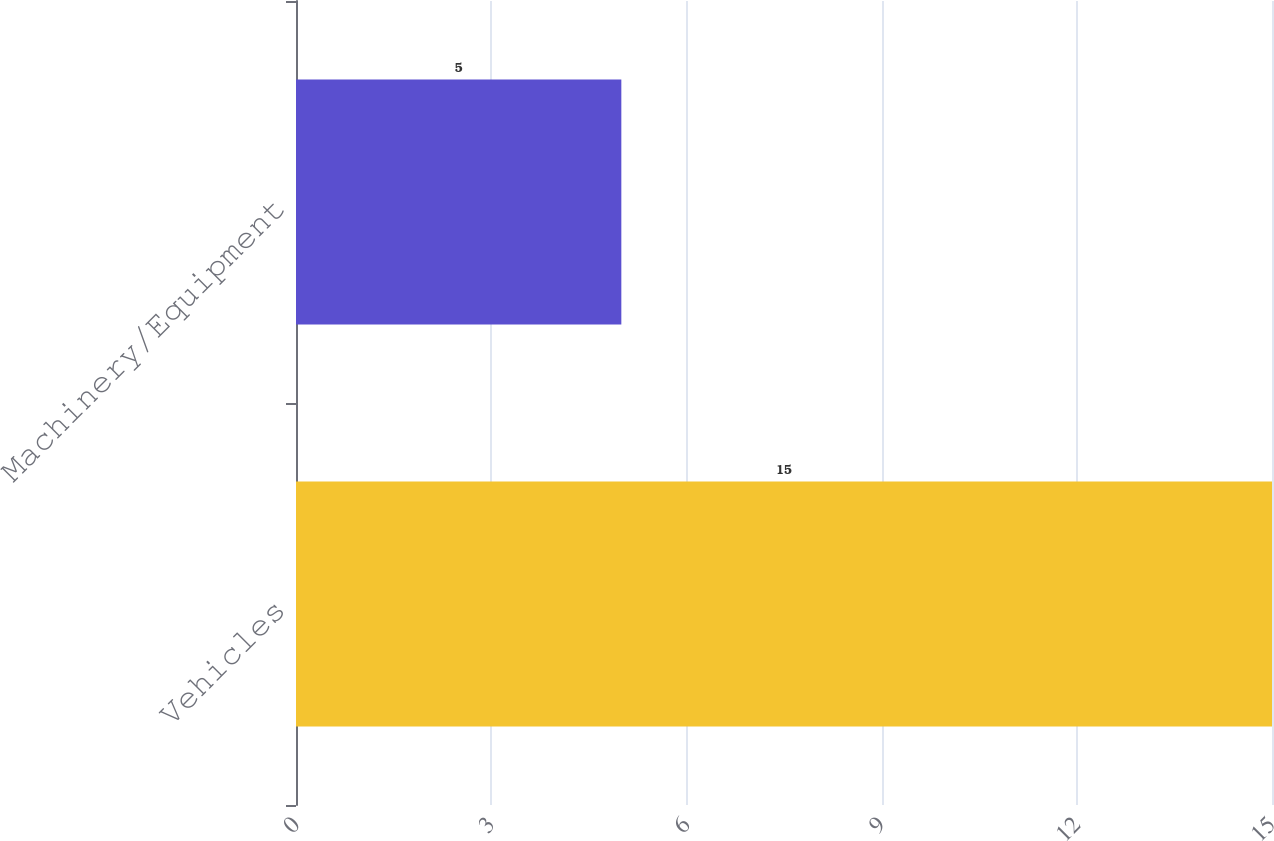Convert chart. <chart><loc_0><loc_0><loc_500><loc_500><bar_chart><fcel>Vehicles<fcel>Machinery/Equipment<nl><fcel>15<fcel>5<nl></chart> 